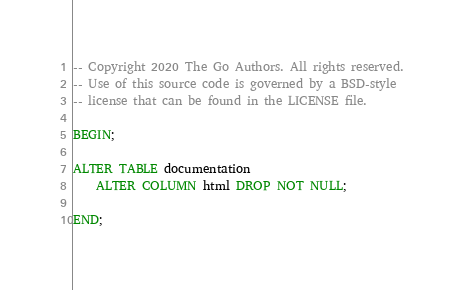<code> <loc_0><loc_0><loc_500><loc_500><_SQL_>-- Copyright 2020 The Go Authors. All rights reserved.
-- Use of this source code is governed by a BSD-style
-- license that can be found in the LICENSE file.

BEGIN;

ALTER TABLE documentation
    ALTER COLUMN html DROP NOT NULL;

END;
</code> 